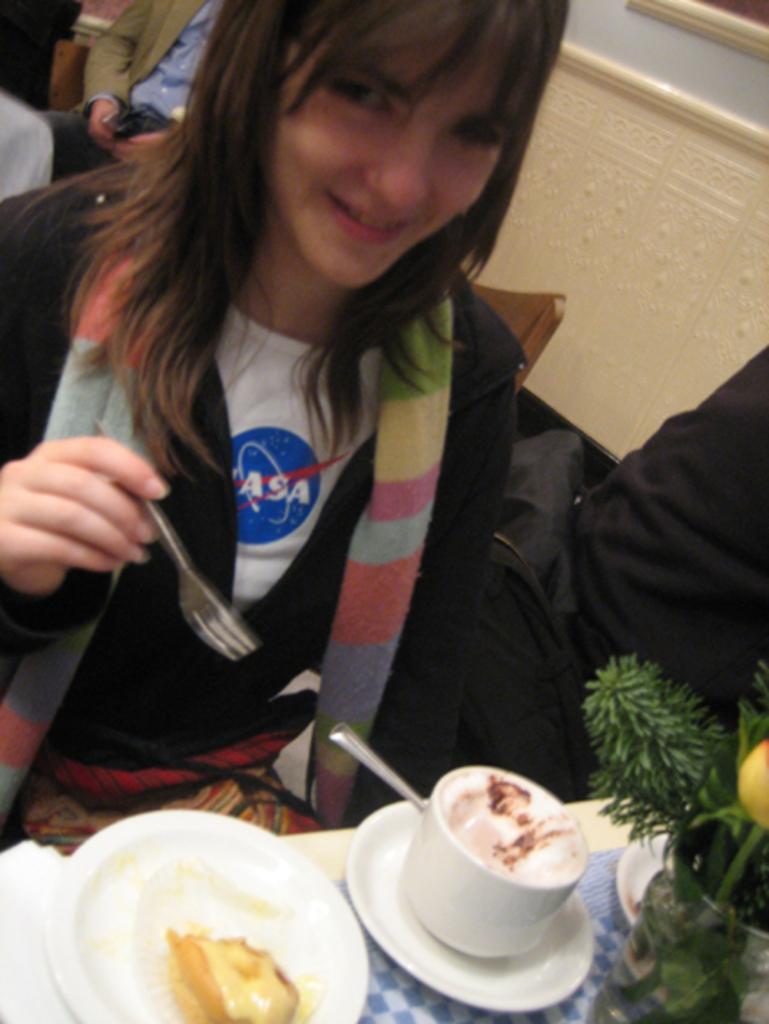Please provide a concise description of this image. In the picture I can see a woman wearing black jacket is holding a fork in her hand and there is a table in front of her which has a cup of coffee,an edible and some other objects on it and there is a person in the right corner and there are few other persons in the background. 